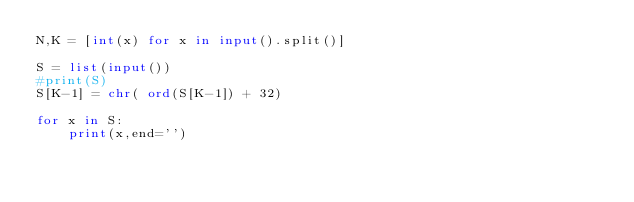<code> <loc_0><loc_0><loc_500><loc_500><_Python_>N,K = [int(x) for x in input().split()]

S = list(input())
#print(S)
S[K-1] = chr( ord(S[K-1]) + 32)

for x in S:
    print(x,end='')
</code> 